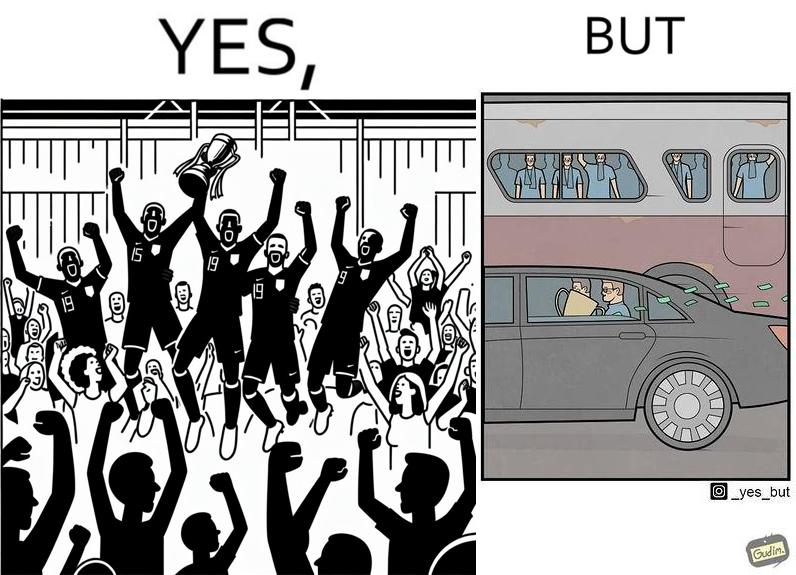What do you see in each half of this image? In the left part of the image: A football team has won some tournament, where the team with the cup are celebrating, along with their fans in the gallery. In the right part of the image: some people are standing in a bus, while some other people are travelling in a car carrying a cup, while cash notes are flowing out the car window. 